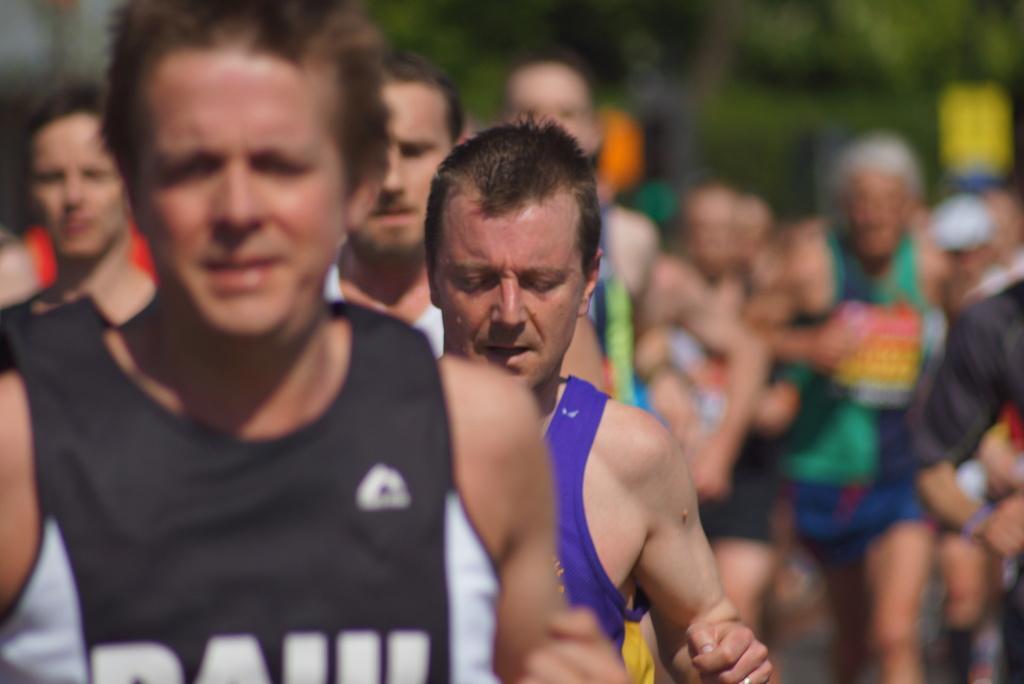Please provide a concise description of this image. In the image few people are running. Background of the image is blur. 